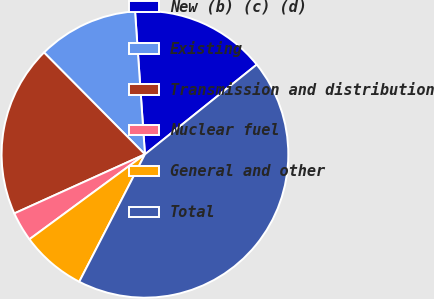Convert chart. <chart><loc_0><loc_0><loc_500><loc_500><pie_chart><fcel>New (b) (c) (d)<fcel>Existing<fcel>Transmission and distribution<fcel>Nuclear fuel<fcel>General and other<fcel>Total<nl><fcel>15.33%<fcel>11.33%<fcel>19.33%<fcel>3.33%<fcel>7.33%<fcel>43.34%<nl></chart> 